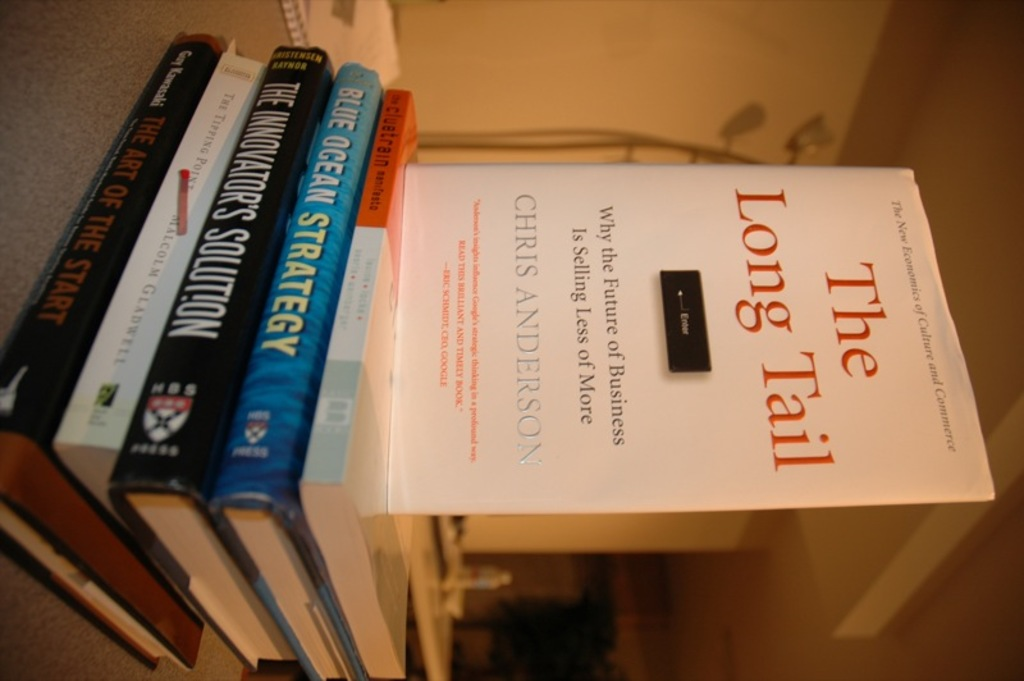What are some main ideas discussed in 'The Long Tail' by Chris Anderson? 'The Long Tail' by Chris Anderson explores the economic model where businesses can profit by selling low volumes of hard-to-find items to many customers, instead of only selling large volumes of a reduced number of popular items. It discusses the rise of niche markets as the world becomes increasingly connected and digital. 